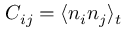Convert formula to latex. <formula><loc_0><loc_0><loc_500><loc_500>C _ { i j } = \langle n _ { i } n _ { j } \rangle _ { t }</formula> 